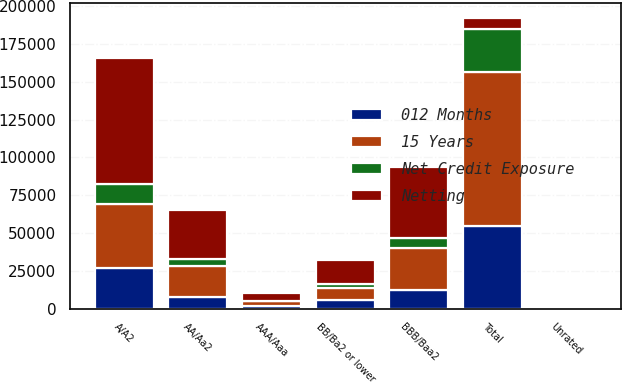Convert chart. <chart><loc_0><loc_0><loc_500><loc_500><stacked_bar_chart><ecel><fcel>AAA/Aaa<fcel>AA/Aa2<fcel>A/A2<fcel>BBB/Baa2<fcel>BB/Ba2 or lower<fcel>Unrated<fcel>Total<nl><fcel>Net Credit Exposure<fcel>494<fcel>4631<fcel>13422<fcel>7032<fcel>2489<fcel>326<fcel>28394<nl><fcel>012 Months<fcel>1934<fcel>7483<fcel>26550<fcel>12173<fcel>5762<fcel>927<fcel>54829<nl><fcel>15 Years<fcel>2778<fcel>20357<fcel>42797<fcel>27676<fcel>7676<fcel>358<fcel>101642<nl><fcel>Netting<fcel>5206<fcel>32471<fcel>82769<fcel>46881<fcel>15927<fcel>1611<fcel>7676<nl></chart> 